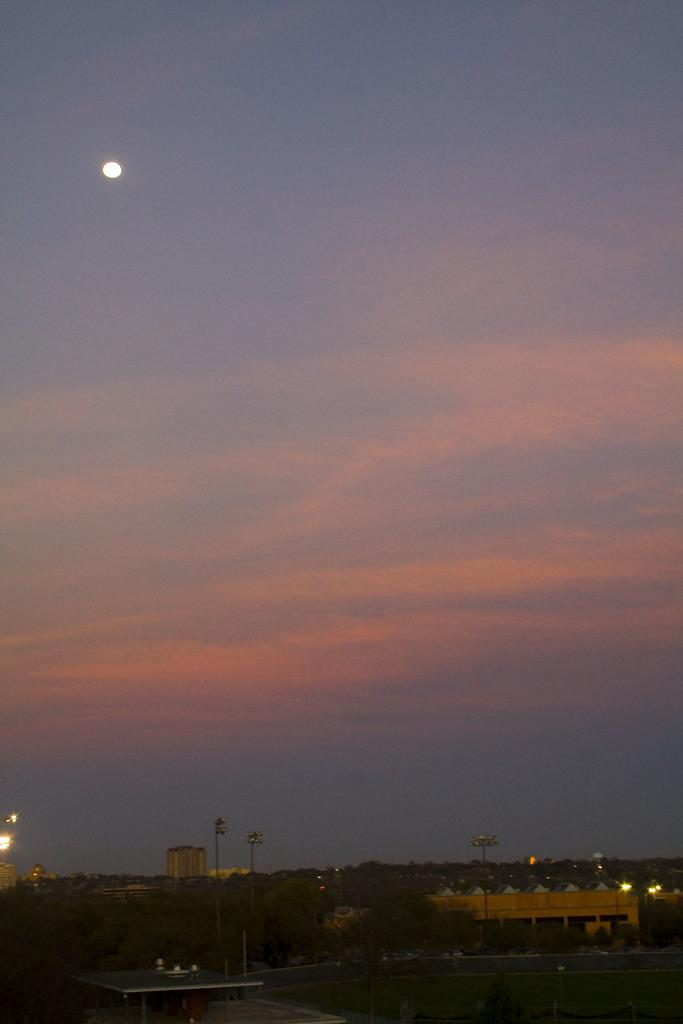What is located at the bottom of the image? There is a road, trees, street lights, poles, and buildings at the bottom of the image. What type of vegetation is present at the bottom of the image? Trees are present at the bottom of the image. What type of lighting is visible at the bottom of the image? Street lights are present at the bottom of the image. What is visible at the top of the image? The sky is visible at the top of the image, and the moon is visible in the sky. Can you describe the setting of the image? The image might have been taken outside the city, given the presence of trees and the absence of tall buildings. What type of cloth is draped over the nest in the image? There is no cloth or nest present in the image. How does the steam escape from the buildings in the image? There is no steam present in the image; it is a clear night sky with the moon visible. 